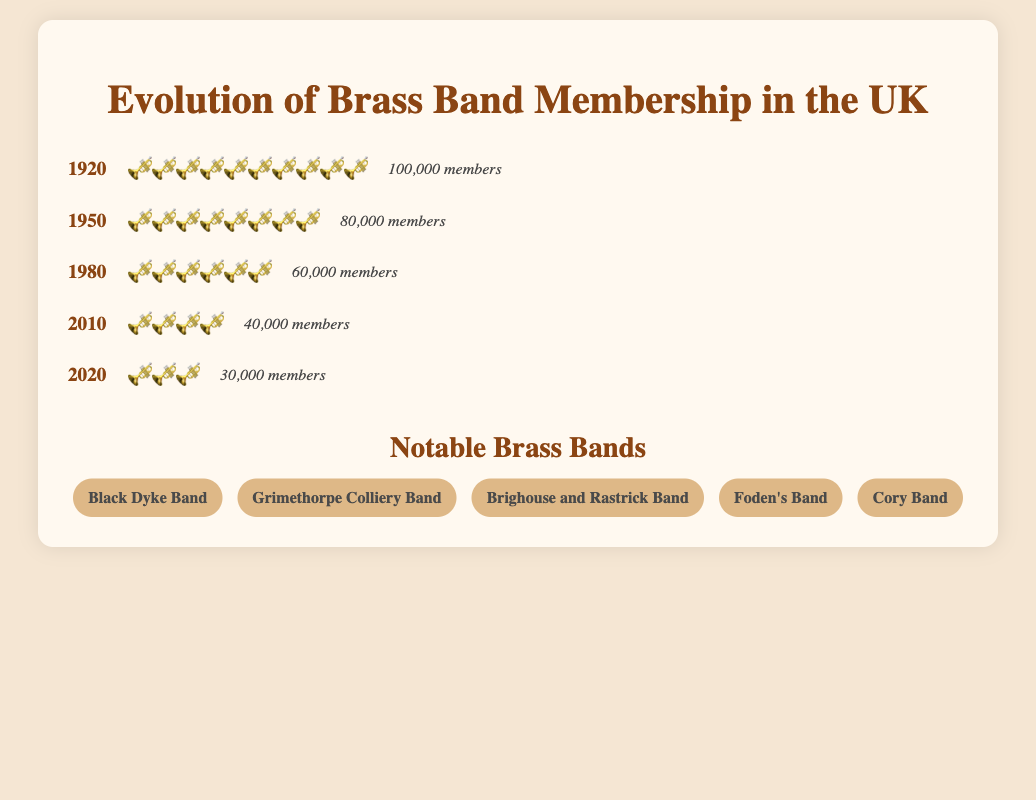What year had the highest brass band membership? The figure shows the membership numbers for different years, and 1920 had the highest membership with 100,000 members.
Answer: 1920 How many years are shown in the figure? The figure presents data in separate year groups with corresponding memberships and icons. By counting them, we see there are 5 years shown: 1920, 1950, 1980, 2010, and 2020.
Answer: 5 What's the total membership decline from 1920 to 2020? We subtract the membership in 2020 (30,000) from the membership in 1920 (100,000): 100,000 - 30,000 = 70,000.
Answer: 70,000 Which year had twice the number of members as the year 2020? The membership in 2020 was 30,000. The year with twice this amount is 2010, which had 40,000 members.
Answer: 2010 What trend can be observed from the given years' membership data? Observing the memberships decreases progressively from 1920 to 2020, shrinking each decade, indicating a declining trend in brass band membership over the century.
Answer: Declining trend How many more members were there in 1950 compared to 2010? We compare the memberships: 80,000 in 1950 and 40,000 in 2010. So, the difference is 80,000 - 40,000 = 40,000.
Answer: 40,000 How many icons (🎺) were used in total across all years? Summing the icons used for each year: 10 (1920) + 8 (1950) + 6 (1980) + 4 (2010) + 3 (2020) = 31.
Answer: 31 If you average the memberships of the years 1920, 1950, and 1980, what is the result? Sum the memberships for these years: 100,000 + 80,000 + 60,000 = 240,000, then divide by 3: 240,000 / 3 = 80,000.
Answer: 80,000 Which year group shows half the membership of 1950? 1950 had 80,000 members, half of which is 40,000. The year 2010 has 40,000 members.
Answer: 2010 What is the decrease in the number of icons (🎺) from 1920 to 2020? 1920 shows 10 icons while 2020 shows 3 icons. The decrease is calculated by: 10 - 3 = 7.
Answer: 7 